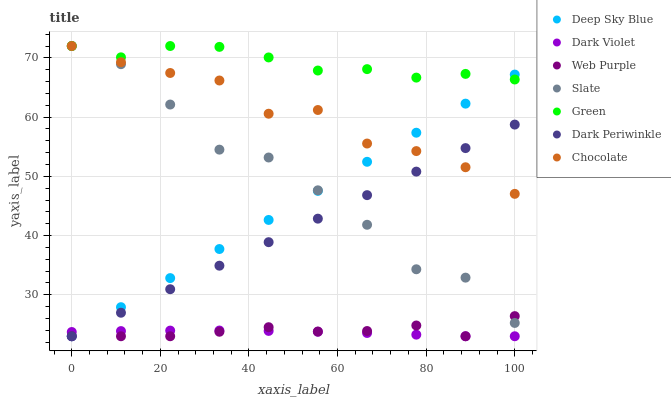Does Dark Violet have the minimum area under the curve?
Answer yes or no. Yes. Does Green have the maximum area under the curve?
Answer yes or no. Yes. Does Chocolate have the minimum area under the curve?
Answer yes or no. No. Does Chocolate have the maximum area under the curve?
Answer yes or no. No. Is Deep Sky Blue the smoothest?
Answer yes or no. Yes. Is Slate the roughest?
Answer yes or no. Yes. Is Dark Violet the smoothest?
Answer yes or no. No. Is Dark Violet the roughest?
Answer yes or no. No. Does Dark Violet have the lowest value?
Answer yes or no. Yes. Does Chocolate have the lowest value?
Answer yes or no. No. Does Green have the highest value?
Answer yes or no. Yes. Does Dark Violet have the highest value?
Answer yes or no. No. Is Web Purple less than Chocolate?
Answer yes or no. Yes. Is Slate greater than Dark Violet?
Answer yes or no. Yes. Does Slate intersect Chocolate?
Answer yes or no. Yes. Is Slate less than Chocolate?
Answer yes or no. No. Is Slate greater than Chocolate?
Answer yes or no. No. Does Web Purple intersect Chocolate?
Answer yes or no. No. 